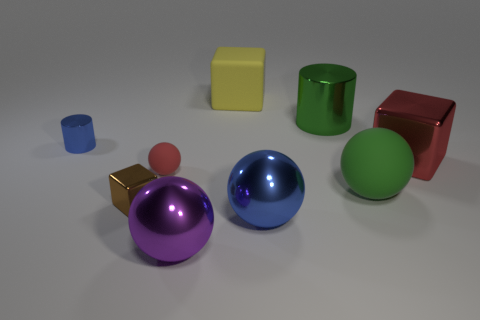The object that is the same color as the large shiny cube is what shape?
Provide a short and direct response. Sphere. What is the color of the other small object that is the same shape as the yellow rubber thing?
Your response must be concise. Brown. There is a rubber ball to the left of the yellow object; is its size the same as the red object on the right side of the green metallic object?
Offer a very short reply. No. Is there a tiny metallic object that has the same shape as the large blue metal object?
Ensure brevity in your answer.  No. Are there the same number of big green shiny objects that are to the left of the tiny block and big gray rubber objects?
Your answer should be very brief. Yes. Does the purple object have the same size as the cylinder behind the small cylinder?
Ensure brevity in your answer.  Yes. How many big yellow cubes have the same material as the small sphere?
Offer a terse response. 1. Does the blue cylinder have the same size as the purple object?
Ensure brevity in your answer.  No. Is there any other thing that is the same color as the big metal cylinder?
Make the answer very short. Yes. There is a object that is on the left side of the small ball and behind the red sphere; what is its shape?
Provide a short and direct response. Cylinder. 